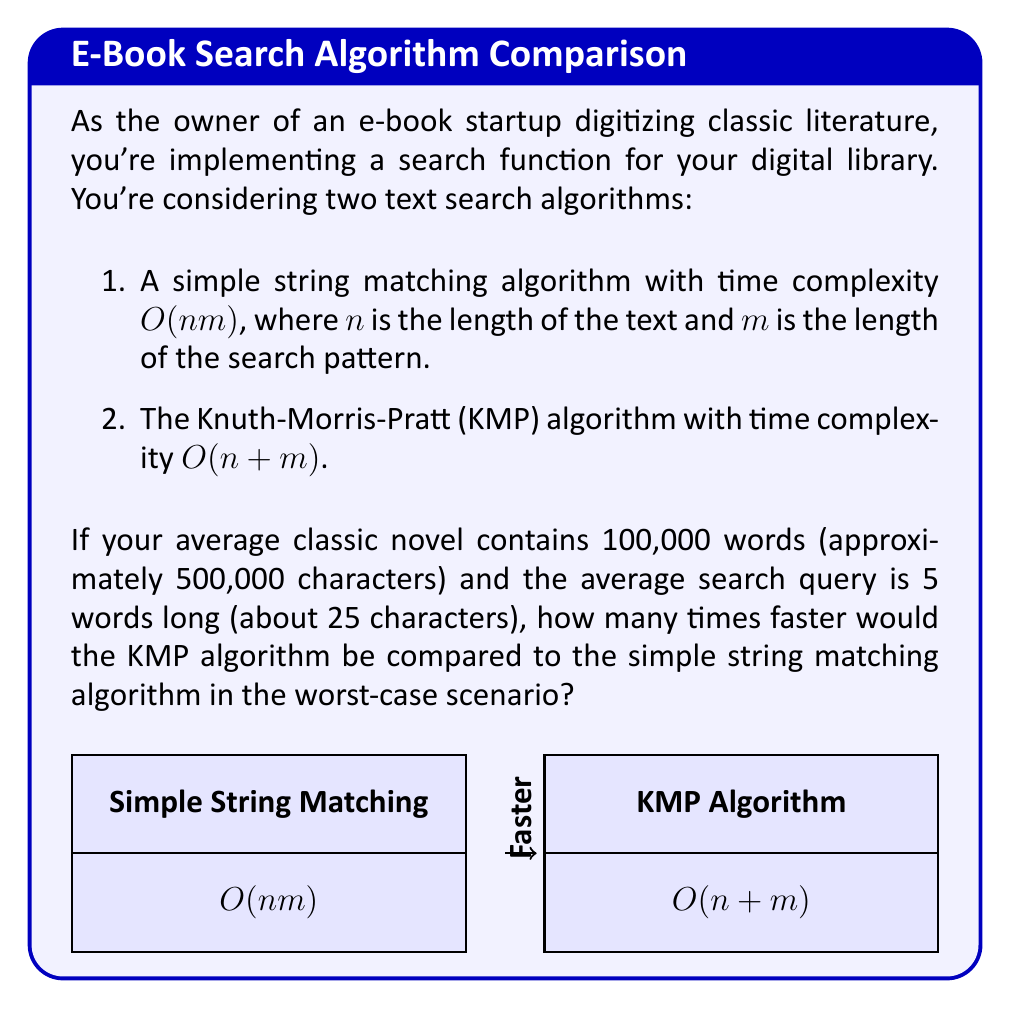Help me with this question. Let's approach this step-by-step:

1) First, let's define our variables:
   $n = 500,000$ (characters in the text)
   $m = 25$ (characters in the search pattern)

2) For the simple string matching algorithm:
   Time complexity = $O(nm) = O(500,000 \times 25) = O(12,500,000)$

3) For the KMP algorithm:
   Time complexity = $O(n+m) = O(500,000 + 25) = O(500,025)$

4) To compare the speed, we need to divide the time complexity of the simple algorithm by the time complexity of KMP:

   $\frac{O(nm)}{O(n+m)} = \frac{12,500,000}{500,025} \approx 24.998$

5) We can round this to 25 for simplicity.

Therefore, in the worst-case scenario, the KMP algorithm would be approximately 25 times faster than the simple string matching algorithm for the given text and pattern lengths.
Answer: 25 times faster 